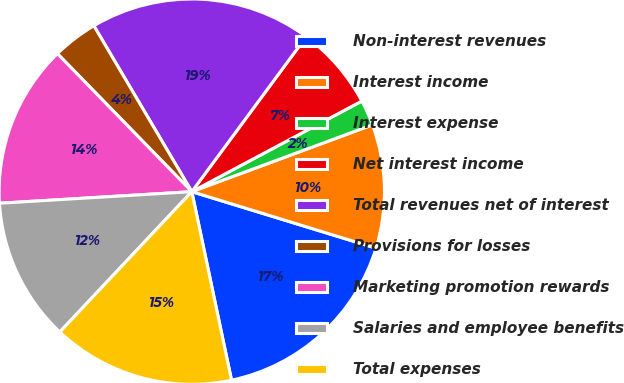<chart> <loc_0><loc_0><loc_500><loc_500><pie_chart><fcel>Non-interest revenues<fcel>Interest income<fcel>Interest expense<fcel>Net interest income<fcel>Total revenues net of interest<fcel>Provisions for losses<fcel>Marketing promotion rewards<fcel>Salaries and employee benefits<fcel>Total expenses<nl><fcel>16.96%<fcel>10.38%<fcel>2.15%<fcel>7.09%<fcel>18.61%<fcel>3.8%<fcel>13.67%<fcel>12.03%<fcel>15.32%<nl></chart> 